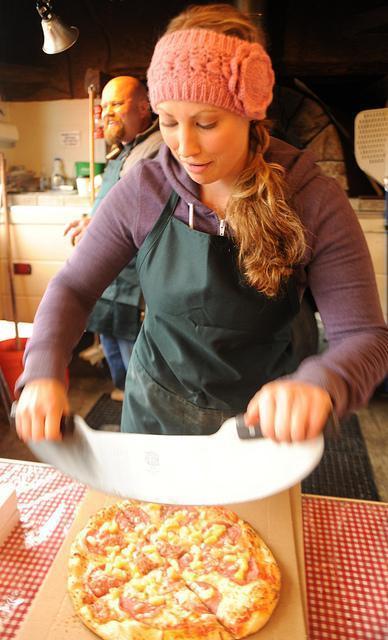How many people can be seen?
Give a very brief answer. 2. How many pizzas are there?
Give a very brief answer. 3. 